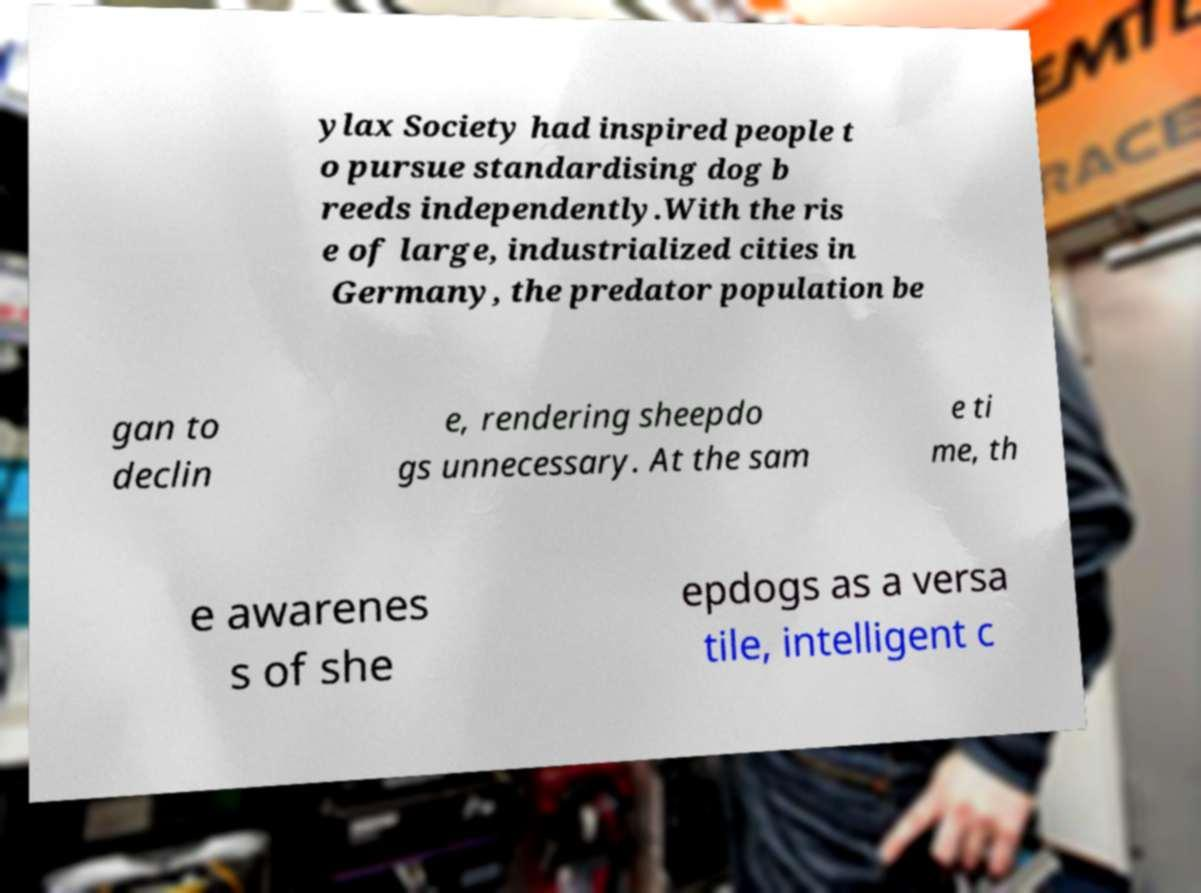Could you assist in decoding the text presented in this image and type it out clearly? ylax Society had inspired people t o pursue standardising dog b reeds independently.With the ris e of large, industrialized cities in Germany, the predator population be gan to declin e, rendering sheepdo gs unnecessary. At the sam e ti me, th e awarenes s of she epdogs as a versa tile, intelligent c 